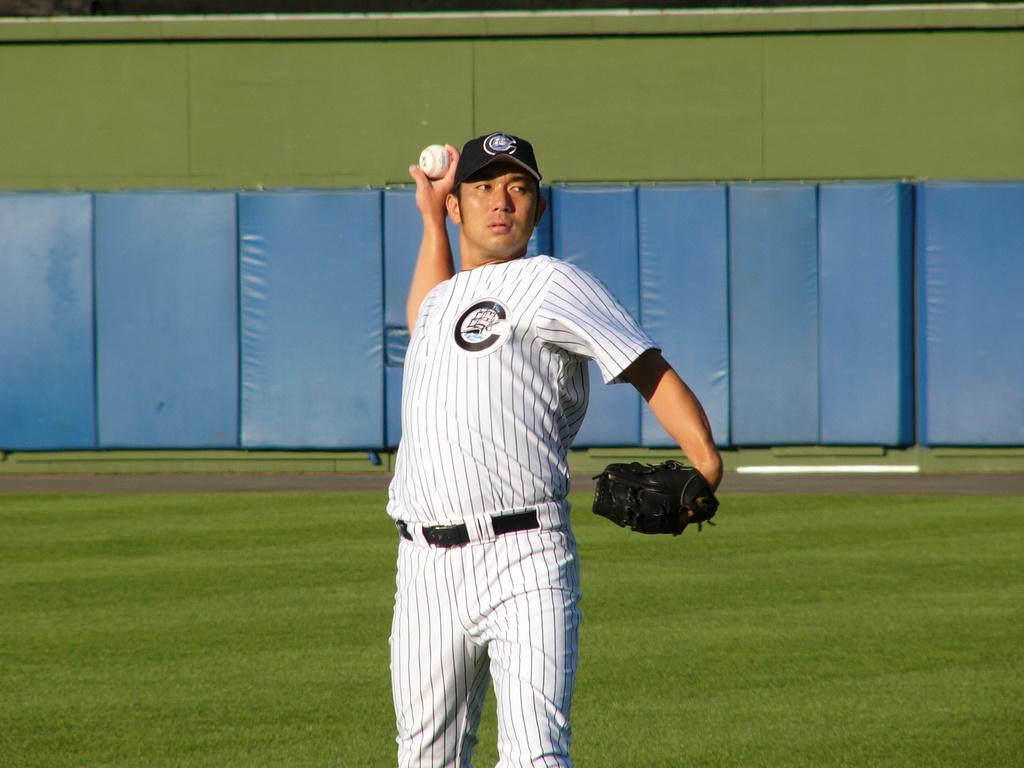What is the man in the image doing? The man is standing in the image and holding a baseball. What type of surface is visible in the image? There is grass visible in the image. What other objects can be seen in the image? There are boards and a wall present in the image. What type of rice can be seen growing in the image? There is no rice present in the image; it features a man holding a baseball and a grassy surface. What type of prose is being recited by the man in the image? There is no indication in the image that the man is reciting any prose. 